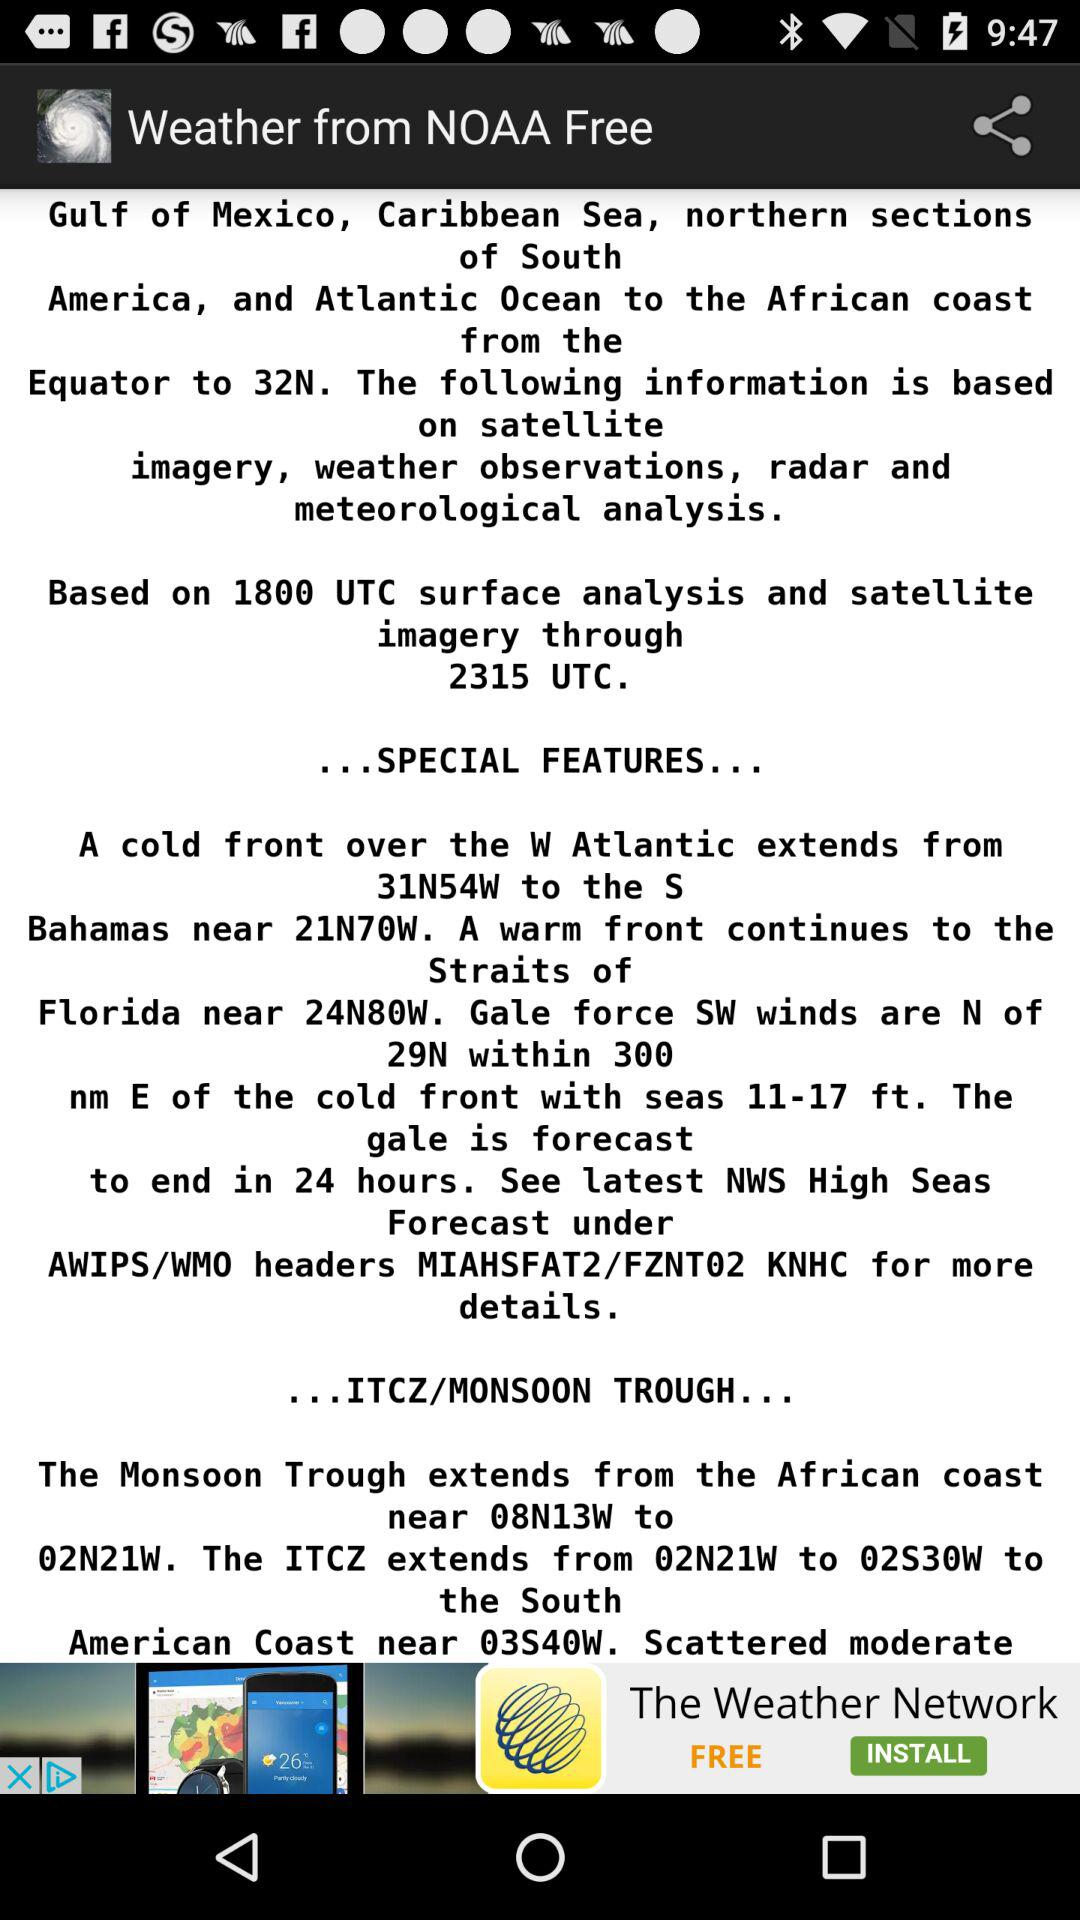What is the name of the application? The name of the application is "Weather from NOAA Free". 